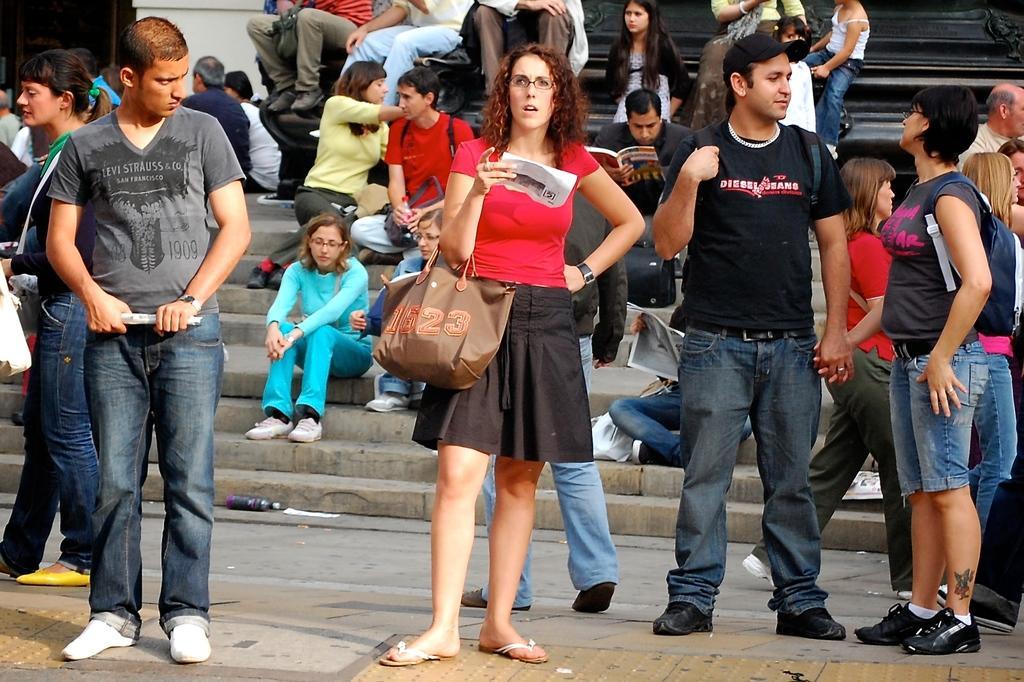Describe this image in one or two sentences. In this image we can see people standing on the floor and sitting on the stairs. In the background there are some people sitting on the bench. 